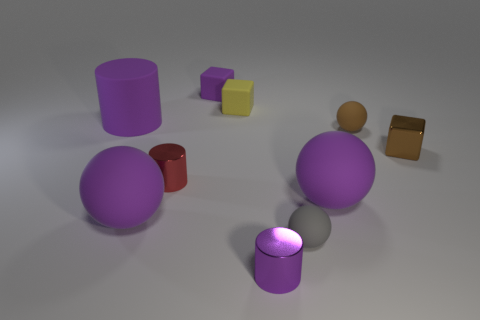Subtract 1 balls. How many balls are left? 3 Subtract all brown balls. Subtract all green cubes. How many balls are left? 3 Subtract all balls. How many objects are left? 6 Add 1 brown metallic things. How many brown metallic things exist? 2 Subtract 1 yellow blocks. How many objects are left? 9 Subtract all red rubber cylinders. Subtract all brown metal objects. How many objects are left? 9 Add 3 large spheres. How many large spheres are left? 5 